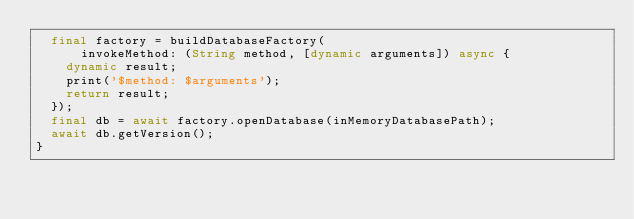<code> <loc_0><loc_0><loc_500><loc_500><_Dart_>  final factory = buildDatabaseFactory(
      invokeMethod: (String method, [dynamic arguments]) async {
    dynamic result;
    print('$method: $arguments');
    return result;
  });
  final db = await factory.openDatabase(inMemoryDatabasePath);
  await db.getVersion();
}
</code> 